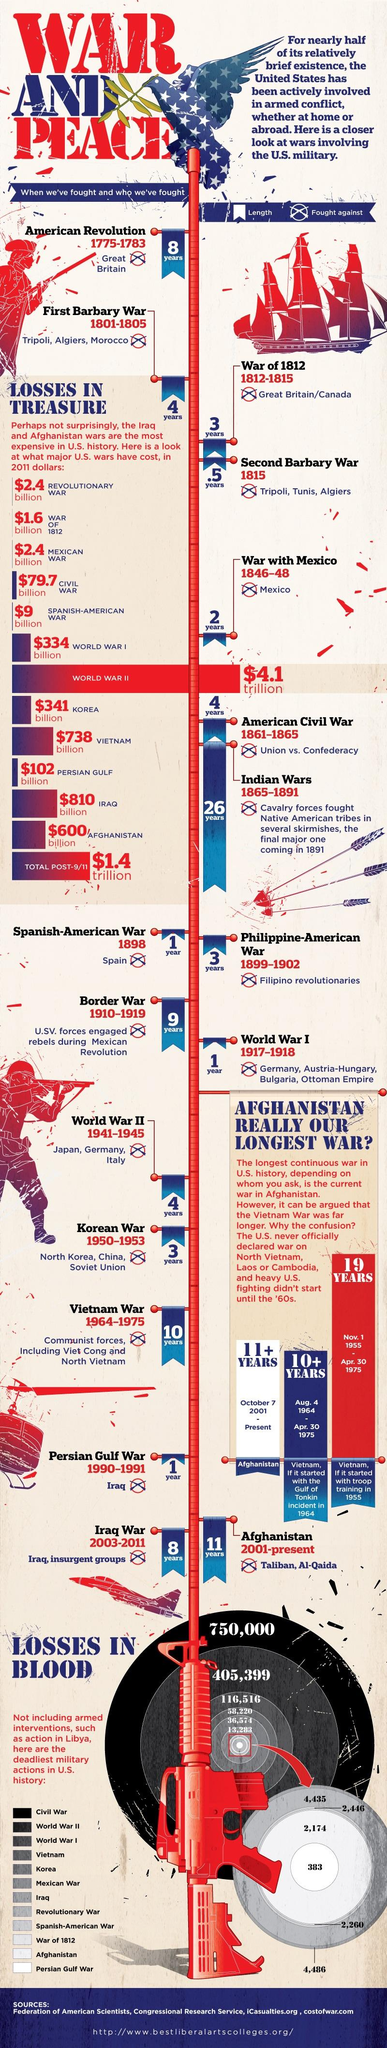List a handful of essential elements in this visual. The War of 1812 was the second war in the history of the United States. During World War II, a total of 405,399 U.S. military service members suffered casualties, including 42,402 who lost their lives. The First Barbary War lasted for a period of 4 years. The Korean War ended in 1953. World War II is the most expensive war in the history of the United States. 